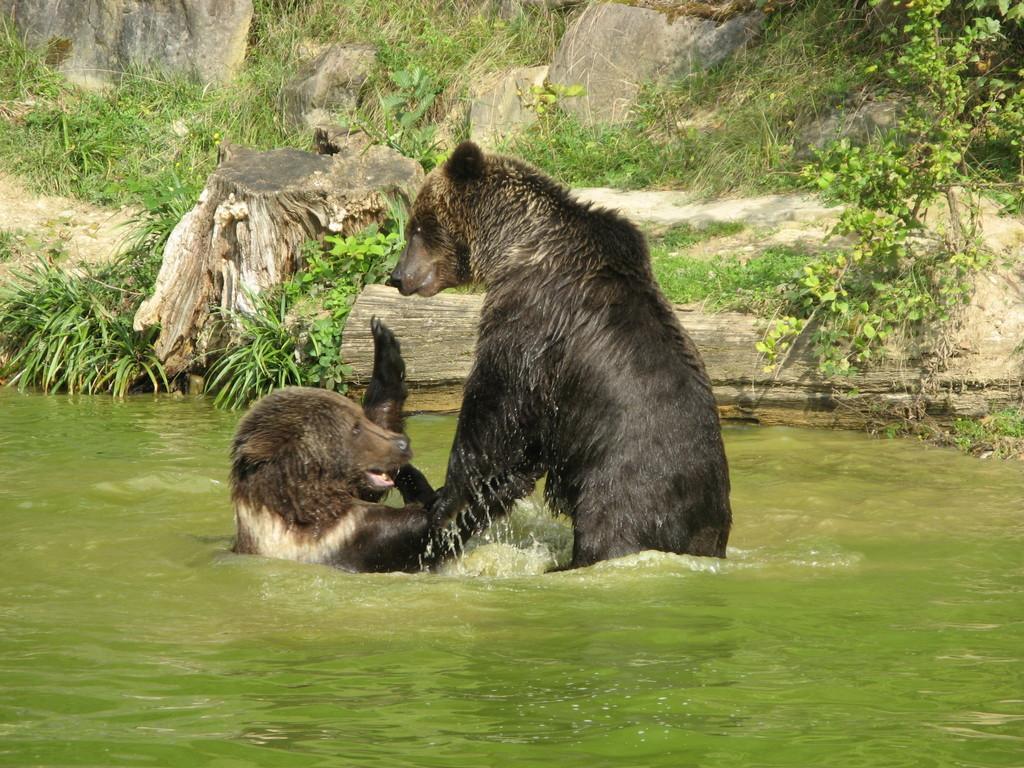In one or two sentences, can you explain what this image depicts? This picture is clicked outside. In the center we can see the animals in the water body. In the background we can see the rocks, green grass and plants. 